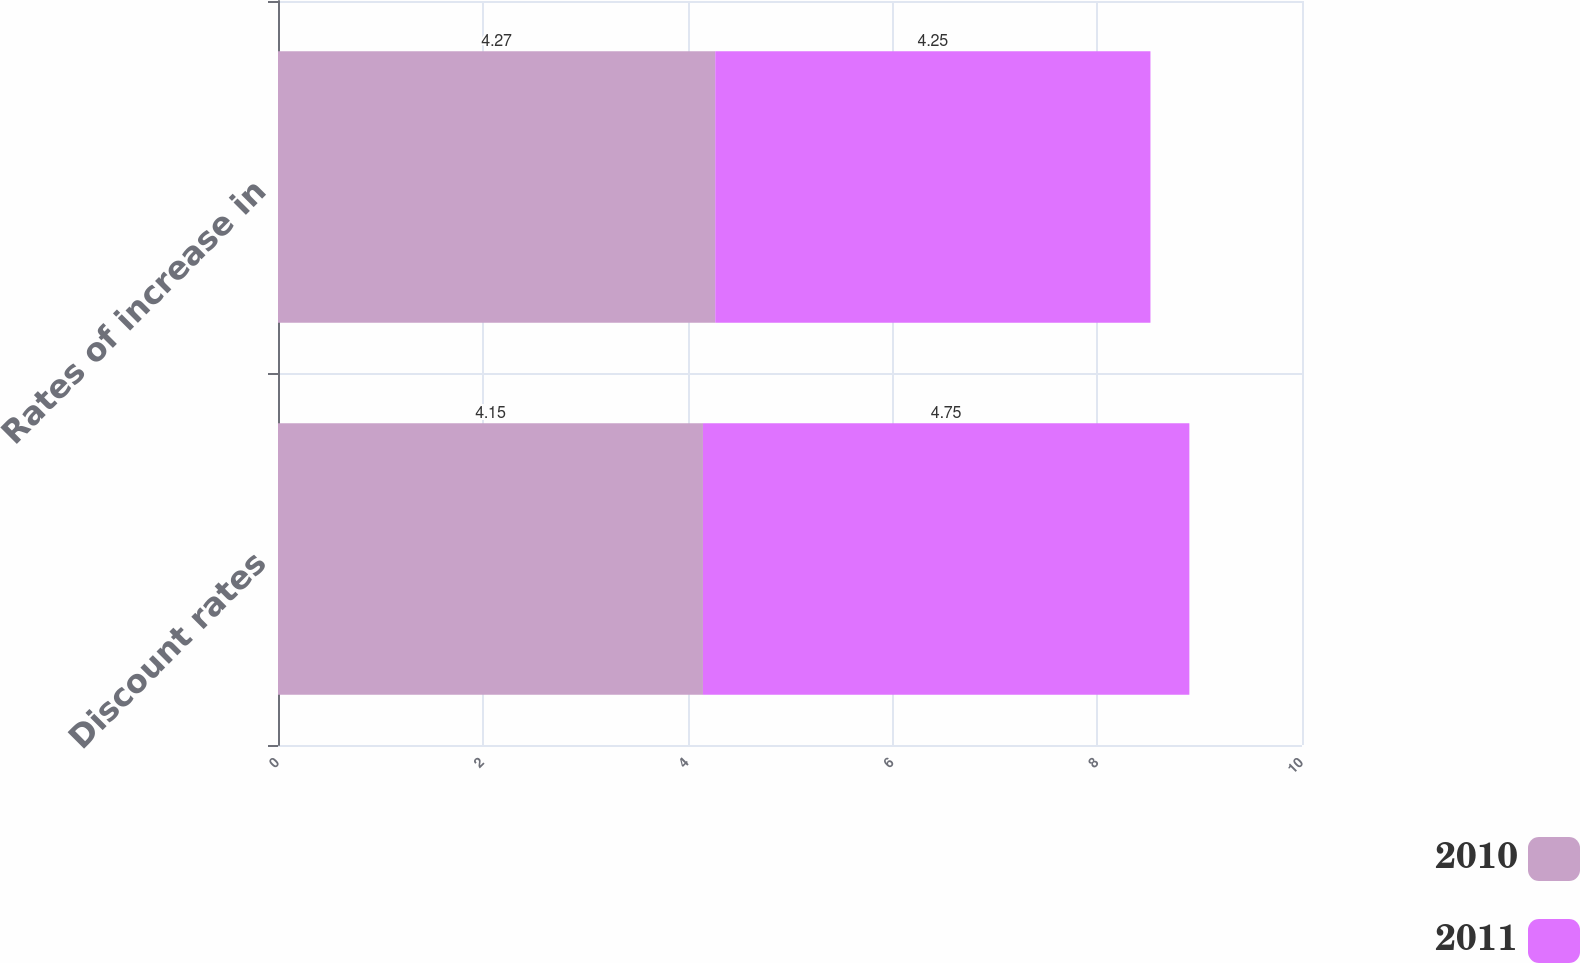Convert chart to OTSL. <chart><loc_0><loc_0><loc_500><loc_500><stacked_bar_chart><ecel><fcel>Discount rates<fcel>Rates of increase in<nl><fcel>2010<fcel>4.15<fcel>4.27<nl><fcel>2011<fcel>4.75<fcel>4.25<nl></chart> 